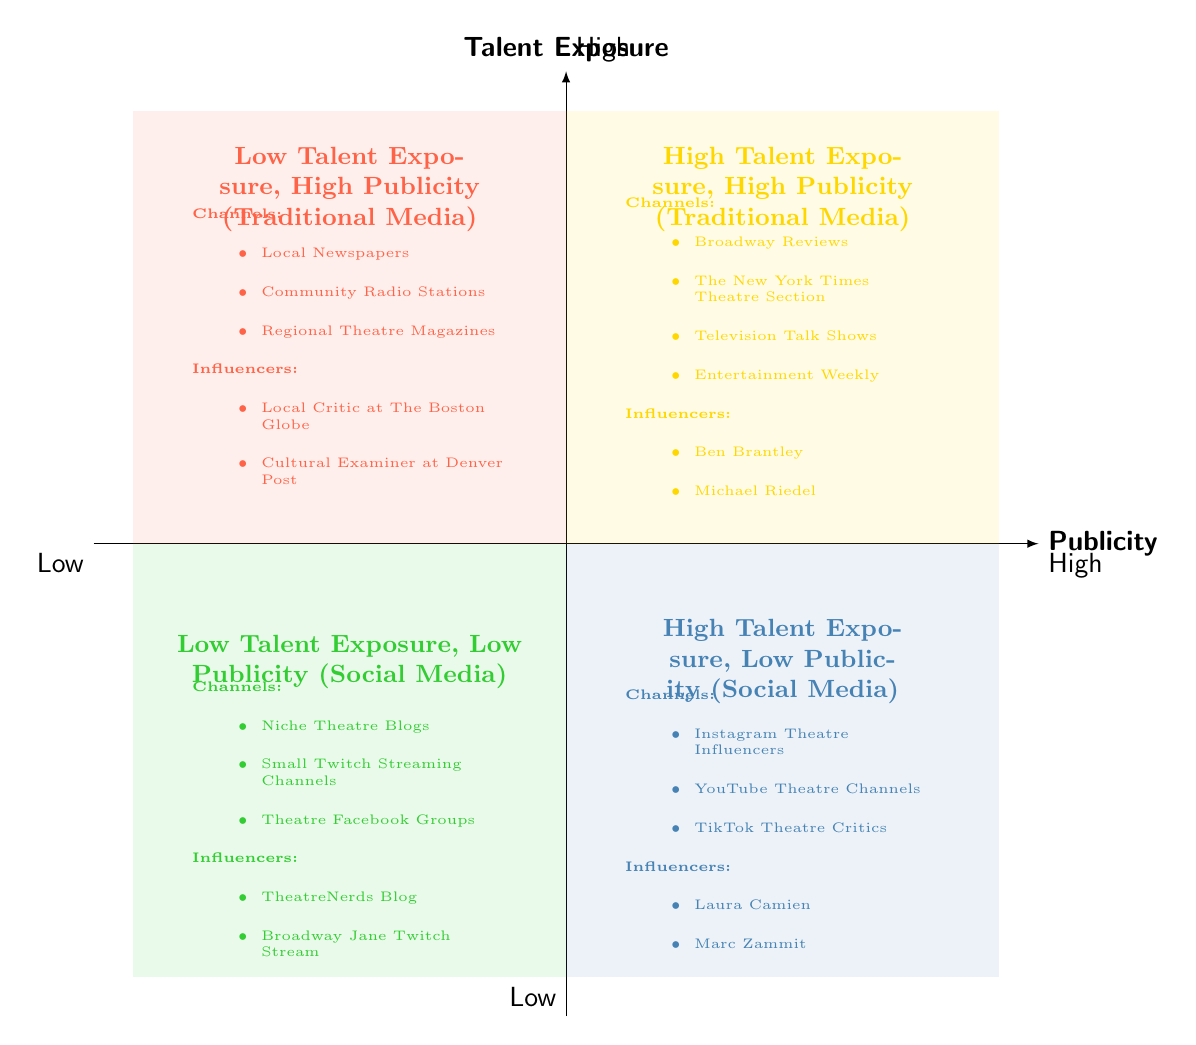What are the channels listed in the High Talent Exposure, High Publicity quadrant? In the diagram, the High Talent Exposure, High Publicity quadrant contains a list of channels: Broadway Reviews, The New York Times Theatre Section, Television Talk Shows, and Entertainment Weekly. These are explicitly mentioned under that quadrant.
Answer: Broadway Reviews, The New York Times Theatre Section, Television Talk Shows, Entertainment Weekly Which influencers are associated with Low Talent Exposure, High Publicity? The Low Talent Exposure, High Publicity quadrant includes influencers Local Critic at The Boston Globe and Cultural Examiner at Denver Post. This information is directly stated in the respective quadrant of the diagram.
Answer: Local Critic at The Boston Globe, Cultural Examiner at Denver Post How many channels are listed under High Talent Exposure, Low Publicity? In the High Talent Exposure, Low Publicity quadrant, there are three channels mentioned: Instagram Theatre Influencers, YouTube Theatre Channels, and TikTok Theatre Critics. Thus, the count of channels here is three.
Answer: 3 Which quadrant has influencers that primarily use Social Media? The quadrants that include influencers using Social Media are High Talent Exposure, Low Publicity and Low Talent Exposure, Low Publicity. Both quadrants reference channels linked to social media platforms, while the influencers listed in those quadrants are associated with them.
Answer: High Talent Exposure, Low Publicity; Low Talent Exposure, Low Publicity What is the relationship between Local Newspapers and High Talent Exposure? Local Newspapers are categorized under the Low Talent Exposure, High Publicity quadrant, indicating that they provide channels with a significant amount of publicity but do not result in high exposure for talents. This relationship can be observed by examining which quadrant they are placed in.
Answer: Low Talent Exposure, High Publicity Which type of media offers High Talent Exposure but Low Publicity? The type of media that offers High Talent Exposure but Low Publicity is Social Media. This is represented in the diagram specifically within the High Talent Exposure, Low Publicity quadrant, outlining social media channels such as Instagram Theatre Influencers and YouTube Theatre Channels.
Answer: Social Media What is the key feature of the Low Talent Exposure, Low Publicity quadrant? The Low Talent Exposure, Low Publicity quadrant features channels and influencers that are not mainstream, suggesting they have little visibility and impact in the theater industry. Niche Theatre Blogs and Small Twitch Streaming Channels are examples provided in the diagram, showcasing this characteristic.
Answer: Niche content Who are the influencers mentioned in the High Talent Exposure, Low Publicity quadrant? In the High Talent Exposure, Low Publicity quadrant, the influencers mentioned are Laura Camien and Marc Zammit. Each influencer has their names explicitly listed under that specific quadrant in the diagram.
Answer: Laura Camien, Marc Zammit 